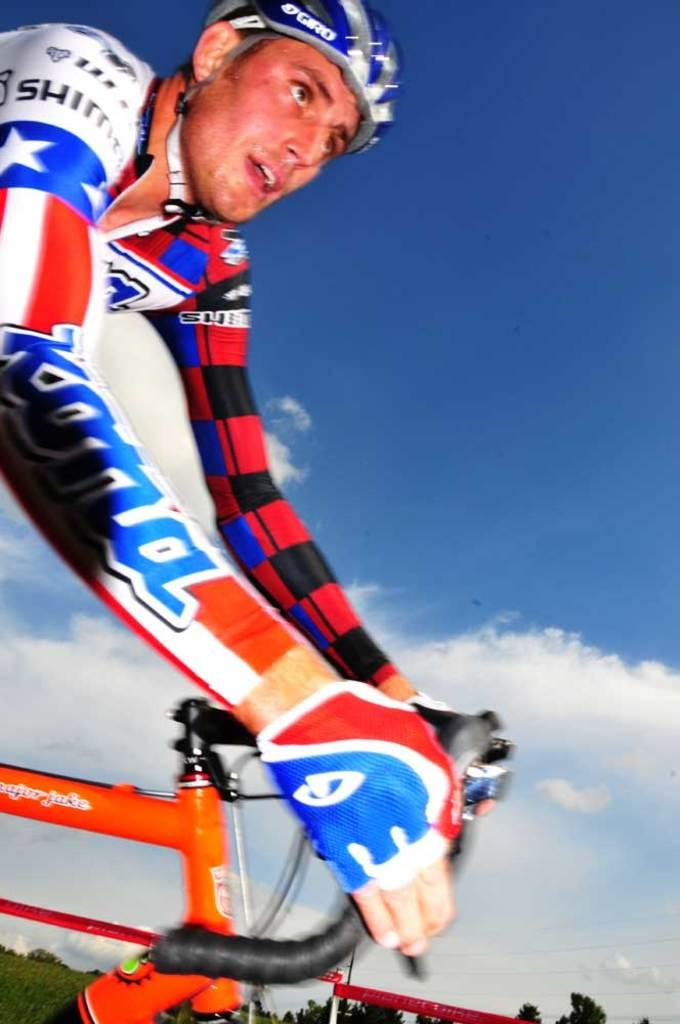Who is the main subject in the image? There is a man in the image. What is the man doing in the image? The man is riding a bicycle. What safety precaution is the man taking while riding the bicycle? The man is wearing a helmet. What can be seen in the background of the image? There is a sky with clouds in the background of the image. What type of vegetation is visible at the bottom of the image? There are trees at the bottom of the image. What type of silver needle can be seen in the man's hand while riding the bicycle? There is no silver needle present in the man's hand or in the image. 